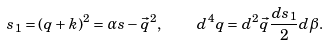Convert formula to latex. <formula><loc_0><loc_0><loc_500><loc_500>s _ { 1 } = ( q + k ) ^ { 2 } = \alpha s - \vec { q } ^ { 2 } , \quad d ^ { 4 } q = d ^ { 2 } \vec { q } \frac { d s _ { 1 } } { 2 } d \beta .</formula> 